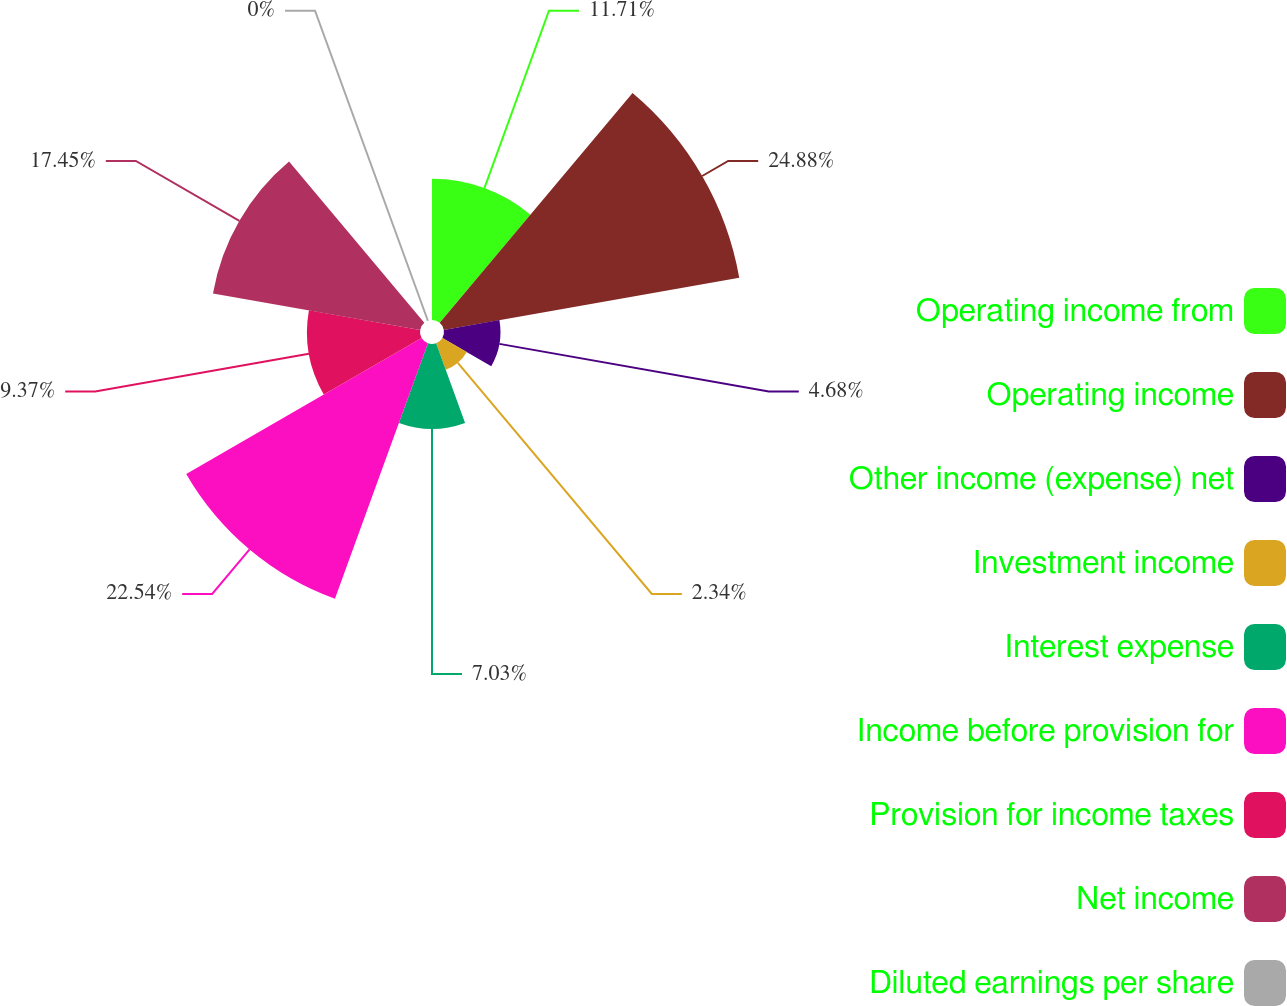<chart> <loc_0><loc_0><loc_500><loc_500><pie_chart><fcel>Operating income from<fcel>Operating income<fcel>Other income (expense) net<fcel>Investment income<fcel>Interest expense<fcel>Income before provision for<fcel>Provision for income taxes<fcel>Net income<fcel>Diluted earnings per share<nl><fcel>11.71%<fcel>24.88%<fcel>4.68%<fcel>2.34%<fcel>7.03%<fcel>22.54%<fcel>9.37%<fcel>17.45%<fcel>0.0%<nl></chart> 